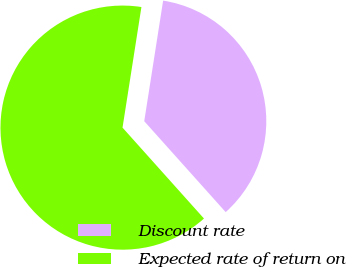Convert chart to OTSL. <chart><loc_0><loc_0><loc_500><loc_500><pie_chart><fcel>Discount rate<fcel>Expected rate of return on<nl><fcel>35.9%<fcel>64.1%<nl></chart> 